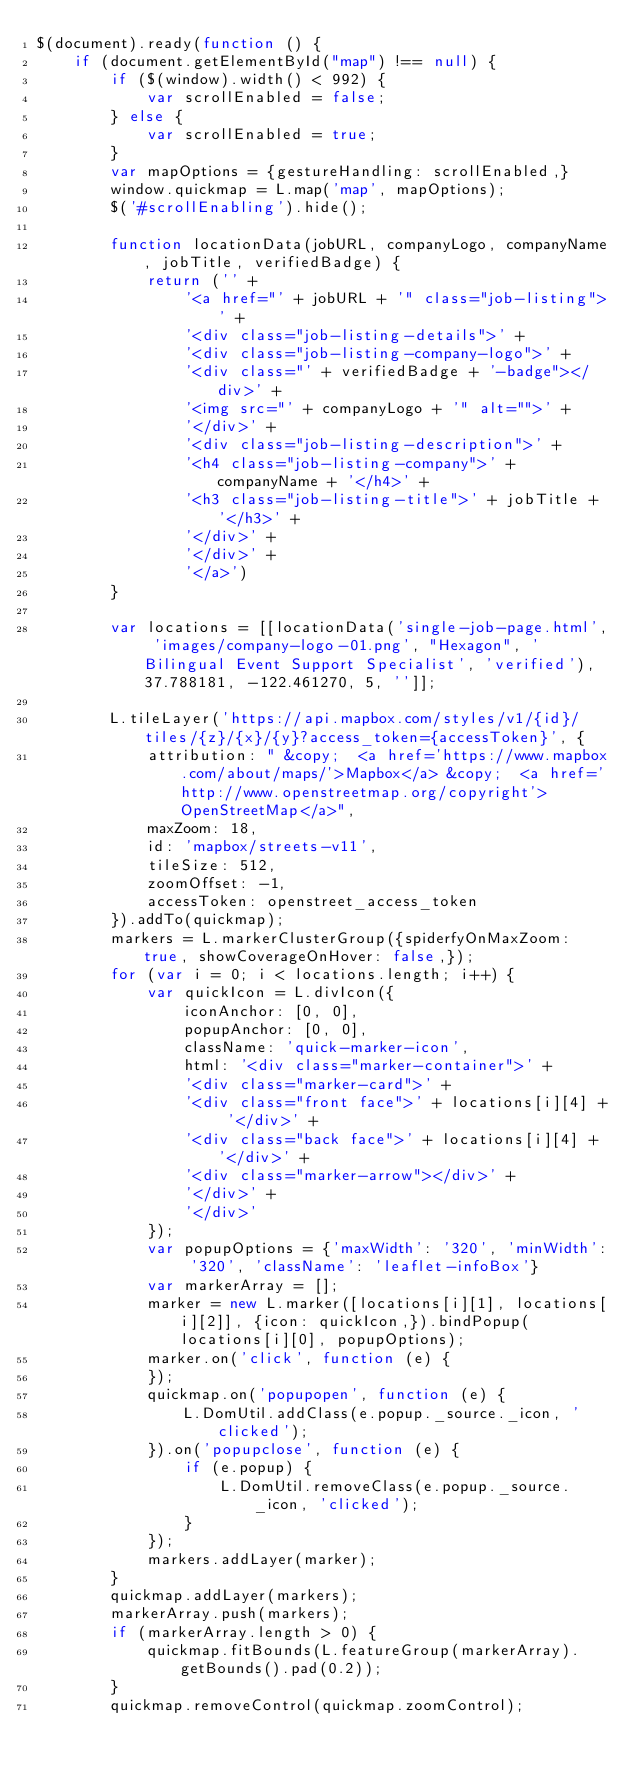Convert code to text. <code><loc_0><loc_0><loc_500><loc_500><_JavaScript_>$(document).ready(function () {
    if (document.getElementById("map") !== null) {
        if ($(window).width() < 992) {
            var scrollEnabled = false;
        } else {
            var scrollEnabled = true;
        }
        var mapOptions = {gestureHandling: scrollEnabled,}
        window.quickmap = L.map('map', mapOptions);
        $('#scrollEnabling').hide();

        function locationData(jobURL, companyLogo, companyName, jobTitle, verifiedBadge) {
            return ('' +
                '<a href="' + jobURL + '" class="job-listing">' +
                '<div class="job-listing-details">' +
                '<div class="job-listing-company-logo">' +
                '<div class="' + verifiedBadge + '-badge"></div>' +
                '<img src="' + companyLogo + '" alt="">' +
                '</div>' +
                '<div class="job-listing-description">' +
                '<h4 class="job-listing-company">' + companyName + '</h4>' +
                '<h3 class="job-listing-title">' + jobTitle + '</h3>' +
                '</div>' +
                '</div>' +
                '</a>')
        }

        var locations = [[locationData('single-job-page.html', 'images/company-logo-01.png', "Hexagon", 'Bilingual Event Support Specialist', 'verified'), 37.788181, -122.461270, 5, '']];

        L.tileLayer('https://api.mapbox.com/styles/v1/{id}/tiles/{z}/{x}/{y}?access_token={accessToken}', {
            attribution: " &copy;  <a href='https://www.mapbox.com/about/maps/'>Mapbox</a> &copy;  <a href='http://www.openstreetmap.org/copyright'>OpenStreetMap</a>",
            maxZoom: 18,
            id: 'mapbox/streets-v11',
            tileSize: 512,
            zoomOffset: -1,
            accessToken: openstreet_access_token
        }).addTo(quickmap);
        markers = L.markerClusterGroup({spiderfyOnMaxZoom: true, showCoverageOnHover: false,});
        for (var i = 0; i < locations.length; i++) {
            var quickIcon = L.divIcon({
                iconAnchor: [0, 0],
                popupAnchor: [0, 0],
                className: 'quick-marker-icon',
                html: '<div class="marker-container">' +
                '<div class="marker-card">' +
                '<div class="front face">' + locations[i][4] + '</div>' +
                '<div class="back face">' + locations[i][4] + '</div>' +
                '<div class="marker-arrow"></div>' +
                '</div>' +
                '</div>'
            });
            var popupOptions = {'maxWidth': '320', 'minWidth': '320', 'className': 'leaflet-infoBox'}
            var markerArray = [];
            marker = new L.marker([locations[i][1], locations[i][2]], {icon: quickIcon,}).bindPopup(locations[i][0], popupOptions);
            marker.on('click', function (e) {
            });
            quickmap.on('popupopen', function (e) {
                L.DomUtil.addClass(e.popup._source._icon, 'clicked');
            }).on('popupclose', function (e) {
                if (e.popup) {
                    L.DomUtil.removeClass(e.popup._source._icon, 'clicked');
                }
            });
            markers.addLayer(marker);
        }
        quickmap.addLayer(markers);
        markerArray.push(markers);
        if (markerArray.length > 0) {
            quickmap.fitBounds(L.featureGroup(markerArray).getBounds().pad(0.2));
        }
        quickmap.removeControl(quickmap.zoomControl);</code> 